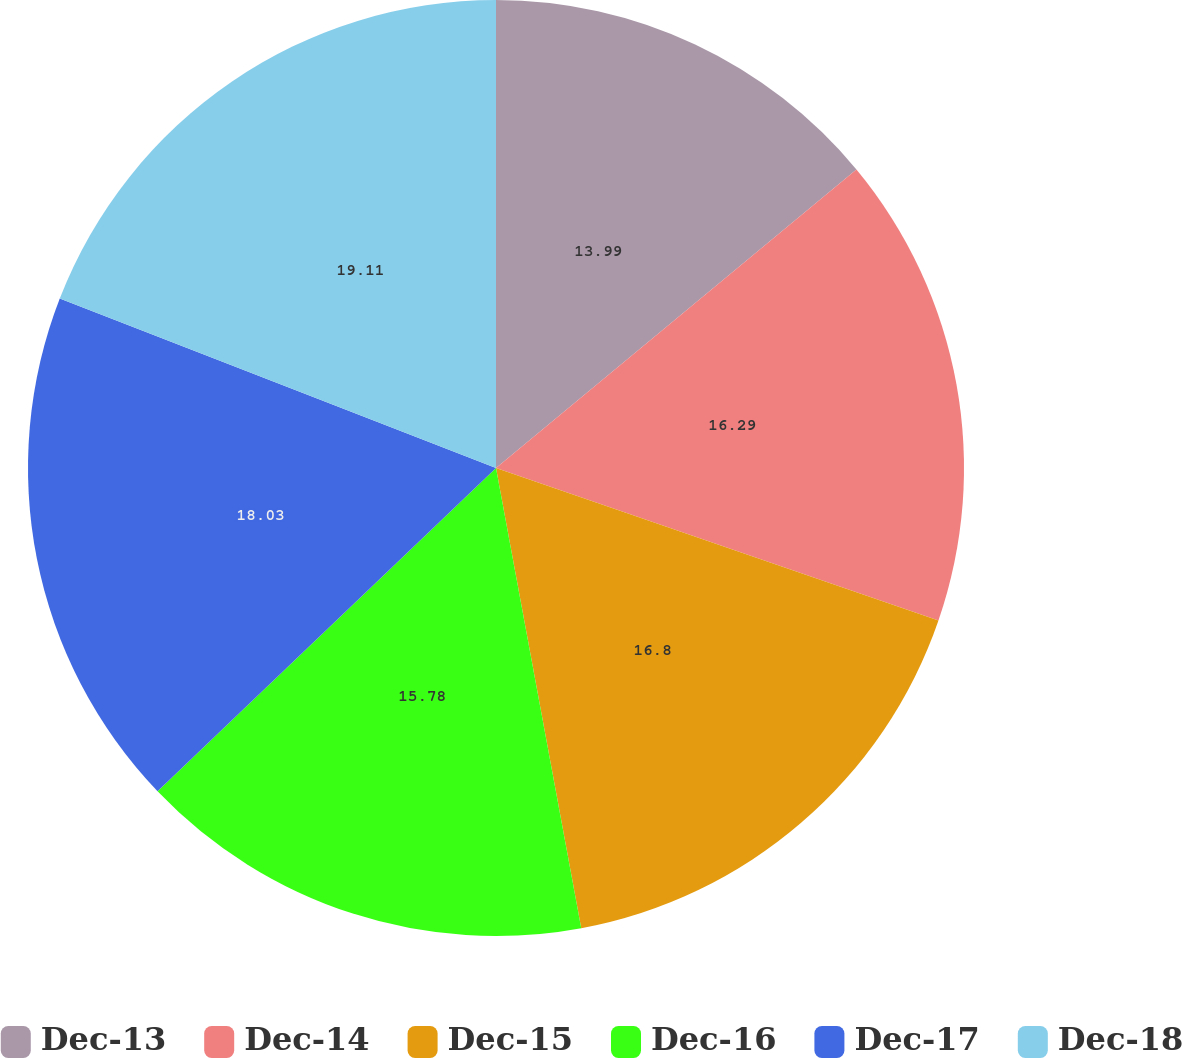Convert chart to OTSL. <chart><loc_0><loc_0><loc_500><loc_500><pie_chart><fcel>Dec-13<fcel>Dec-14<fcel>Dec-15<fcel>Dec-16<fcel>Dec-17<fcel>Dec-18<nl><fcel>13.99%<fcel>16.29%<fcel>16.8%<fcel>15.78%<fcel>18.03%<fcel>19.1%<nl></chart> 